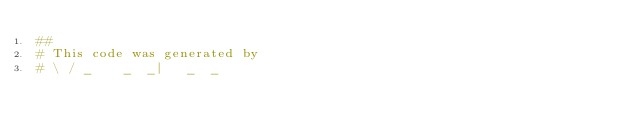<code> <loc_0><loc_0><loc_500><loc_500><_Ruby_>##
# This code was generated by
# \ / _    _  _|   _  _</code> 